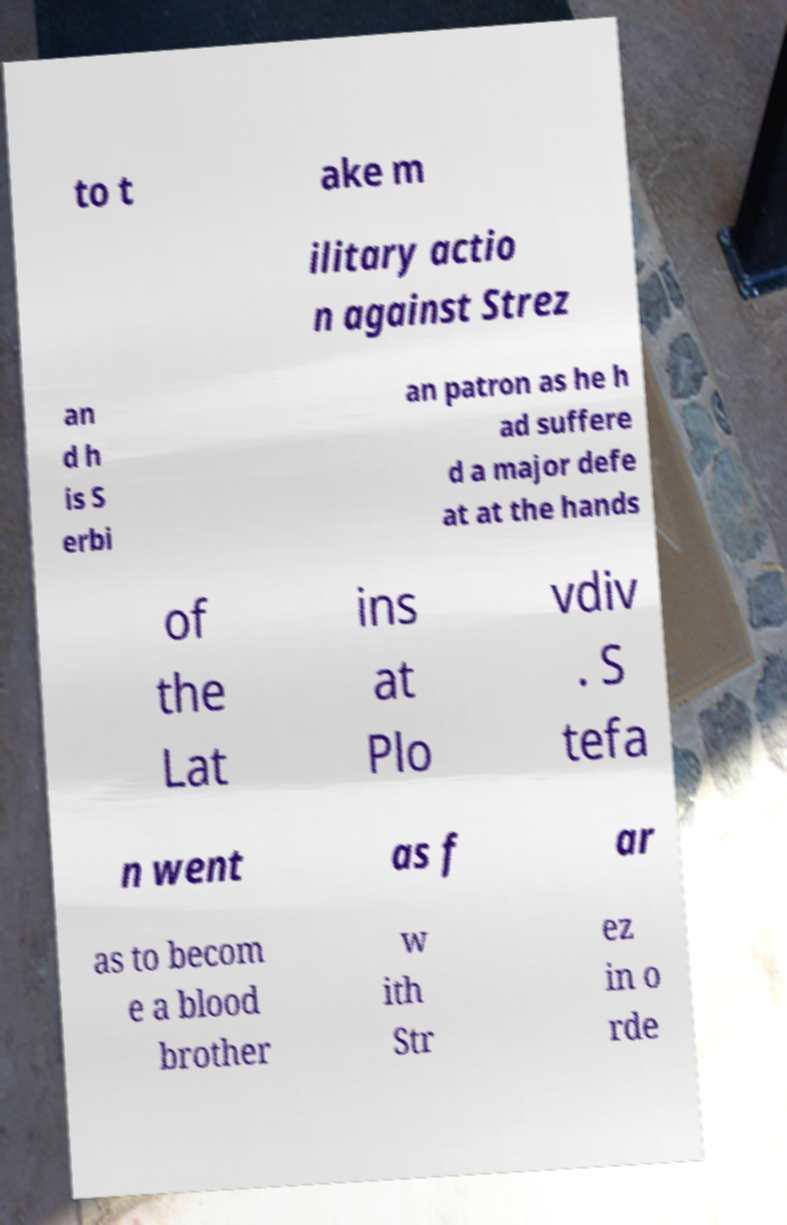There's text embedded in this image that I need extracted. Can you transcribe it verbatim? to t ake m ilitary actio n against Strez an d h is S erbi an patron as he h ad suffere d a major defe at at the hands of the Lat ins at Plo vdiv . S tefa n went as f ar as to becom e a blood brother w ith Str ez in o rde 